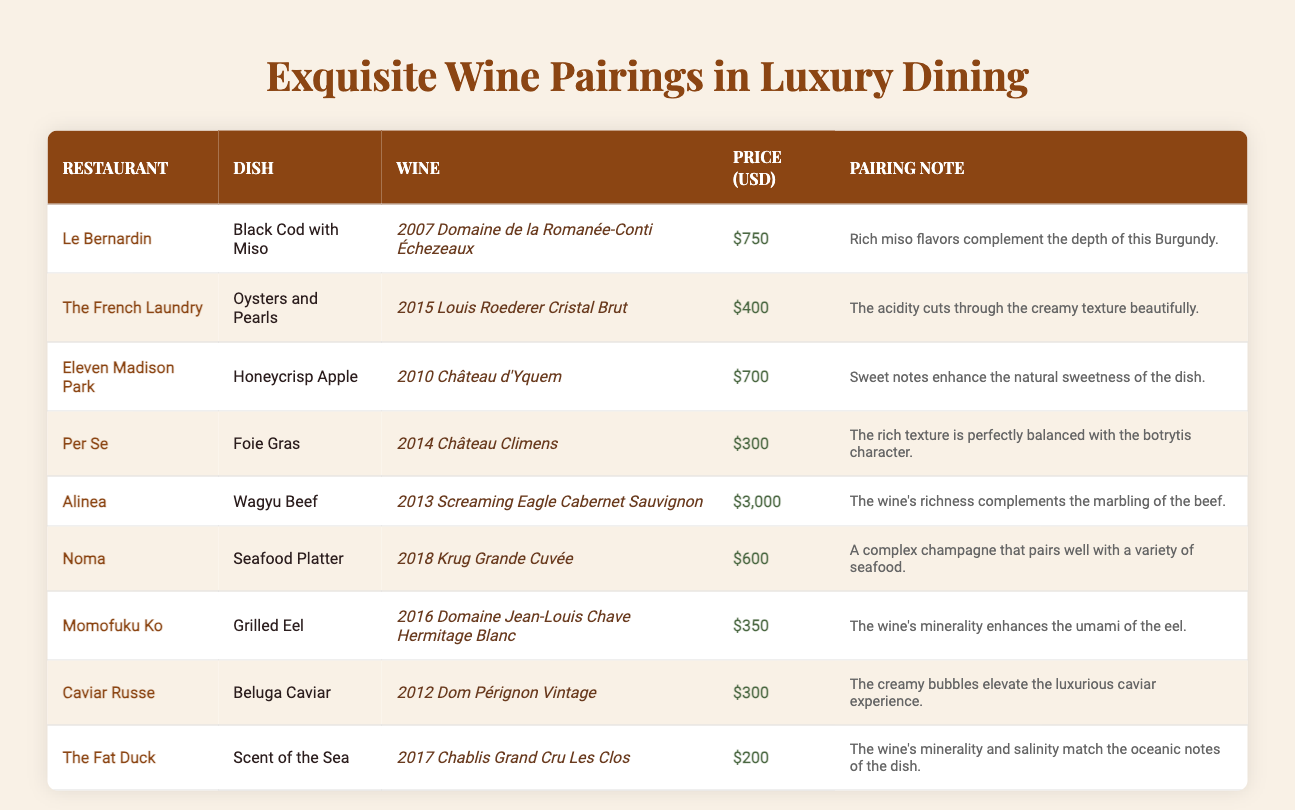What is the most expensive wine pairing on the table? By looking through the price column, the wine pairing with the highest price is the one for Alinea with the Screaming Eagle Cabernet Sauvignon priced at $3,000.
Answer: $3,000 Which restaurant serves Honeycrisp Apple, and what wine is paired with it? The restaurant that serves Honeycrisp Apple is Eleven Madison Park, and it is paired with the 2010 Château d'Yquem.
Answer: Eleven Madison Park; 2010 Château d'Yquem How many wine pairings have a price point below $400? There are three dishes with a price below $400: Foie Gras at Per Se ($300), Beluga Caviar at Caviar Russe ($300), and Scent of the Sea at The Fat Duck ($200).
Answer: 3 Is the pairing note for Oysters and Pearls focused on acidity? Yes, the pairing note indicates that "the acidity cuts through the creamy texture beautifully," confirming the focus on acidity.
Answer: Yes What is the average price of the wine pairings listed? To calculate the average, we first sum all the prices: 750 + 400 + 700 + 300 + 3000 + 600 + 350 + 300 + 200 = 6350. There are 9 pairings, so dividing by 9 gives an average price of approximately $705.56.
Answer: $705.56 Which dish has the lowest price wine pairing? The dish with the lowest price wine pairing is "Scent of the Sea" at The Fat Duck, with a wine pairing costing $200.
Answer: Scent of the Sea; $200 What are the pairings for the restaurant Noma? Noma serves a Seafood Platter paired with the 2018 Krug Grande Cuvée for $600.
Answer: Seafood Platter; 2018 Krug Grande Cuvée; $600 Which wine has a pairing note that mentions "umami"? The pairing note for the wine with umami is for the Grilled Eel at Momofuku Ko, which mentions that "the wine's minerality enhances the umami of the eel."
Answer: 2016 Domaine Jean-Louis Chave Hermitage Blanc How many pairings are associated with wine priced over $600? There are four pairings priced over $600: Black Cod with Miso ($750), Honeycrisp Apple ($700), $600 for the Seafood Platter, and of course, Wagyu Beef at $3000. This includes pairings at Alinea, Le Bernardin, Eleven Madison Park, and Noma.
Answer: 4 